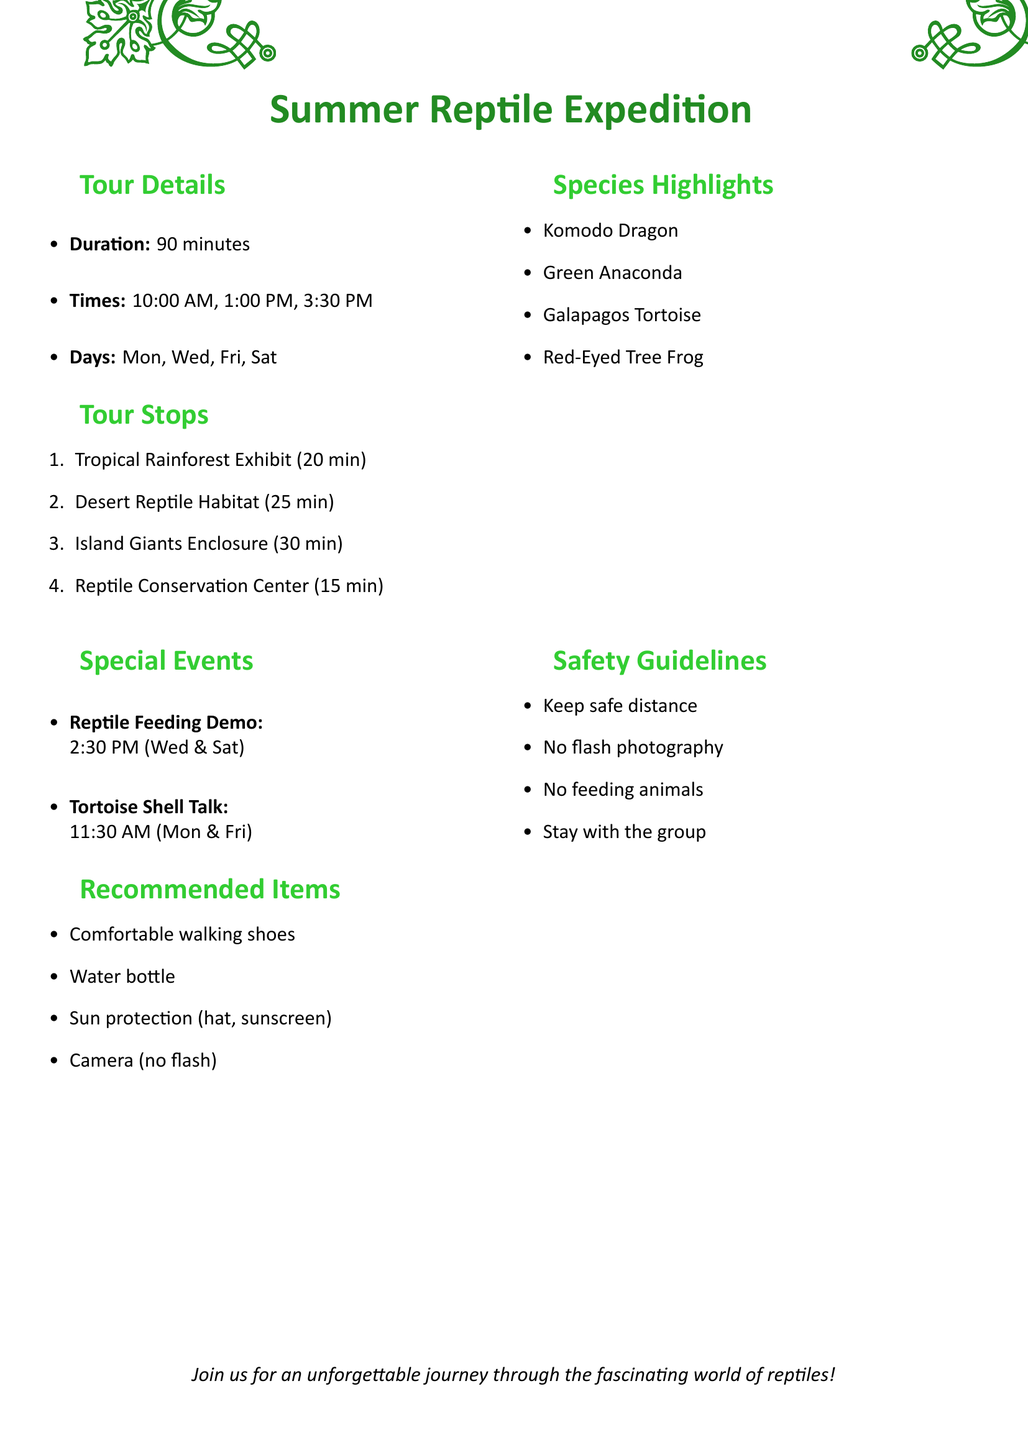What is the name of the tour? The name of the tour is presented at the beginning of the document as the title.
Answer: Summer Reptile Expedition What is the duration of the tour? The duration of the tour is specified in the "Tour Details" section, indicating how long the tour lasts.
Answer: 90 minutes When are the tour times available? The available tour times are listed explicitly in the "Tour Details" section as times when the tours occur.
Answer: 10:00 AM, 1:00 PM, 3:30 PM Which species are highlighted in the tour? The highlighted species are listed in the "Species Highlights" section, showcasing the primary animals featured in the tour.
Answer: Komodo Dragon, Green Anaconda, Galapagos Tortoise, Red-Eyed Tree Frog What is one fun fact about the Galapagos Tortoise? A specific fun fact related to the Galapagos Tortoise is found in its description within the "Species Highlights" section.
Answer: Can live over 100 years and weigh up to 919 pounds What is the focus of the Reptile Conservation Center stop? The focus of this tour stop is mentioned directly in the description of the tour stops.
Answer: Breeding programs and conservation efforts On which days is the Reptile Feeding Demonstration held? The schedule for the special event is detailed under "Special Events," listing specific days for this demonstration.
Answer: Wednesday, Saturday What items are recommended to bring on the tour? A list of items recommended for participants is included in the "Recommended Items" section to enhance their experience.
Answer: Comfortable walking shoes, Water bottle, Sun protection (hat, sunscreen), Camera (no flash) 